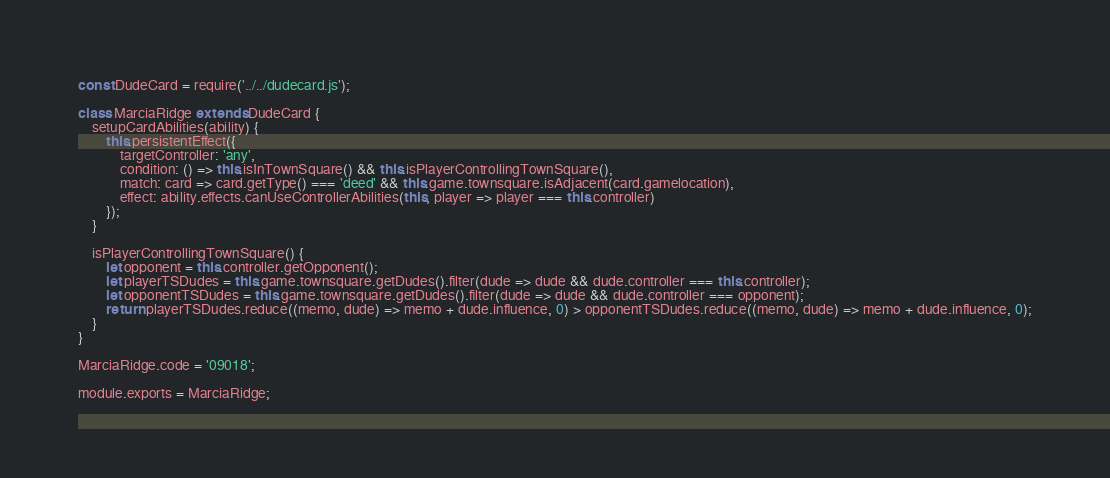Convert code to text. <code><loc_0><loc_0><loc_500><loc_500><_JavaScript_>const DudeCard = require('../../dudecard.js');

class MarciaRidge extends DudeCard {
    setupCardAbilities(ability) {
        this.persistentEffect({
            targetController: 'any',
            condition: () => this.isInTownSquare() && this.isPlayerControllingTownSquare(),
            match: card => card.getType() === 'deed' && this.game.townsquare.isAdjacent(card.gamelocation),
            effect: ability.effects.canUseControllerAbilities(this, player => player === this.controller)
        });
    }

    isPlayerControllingTownSquare() {
        let opponent = this.controller.getOpponent();
        let playerTSDudes = this.game.townsquare.getDudes().filter(dude => dude && dude.controller === this.controller);
        let opponentTSDudes = this.game.townsquare.getDudes().filter(dude => dude && dude.controller === opponent);
        return playerTSDudes.reduce((memo, dude) => memo + dude.influence, 0) > opponentTSDudes.reduce((memo, dude) => memo + dude.influence, 0);
    }
}

MarciaRidge.code = '09018';

module.exports = MarciaRidge;
</code> 